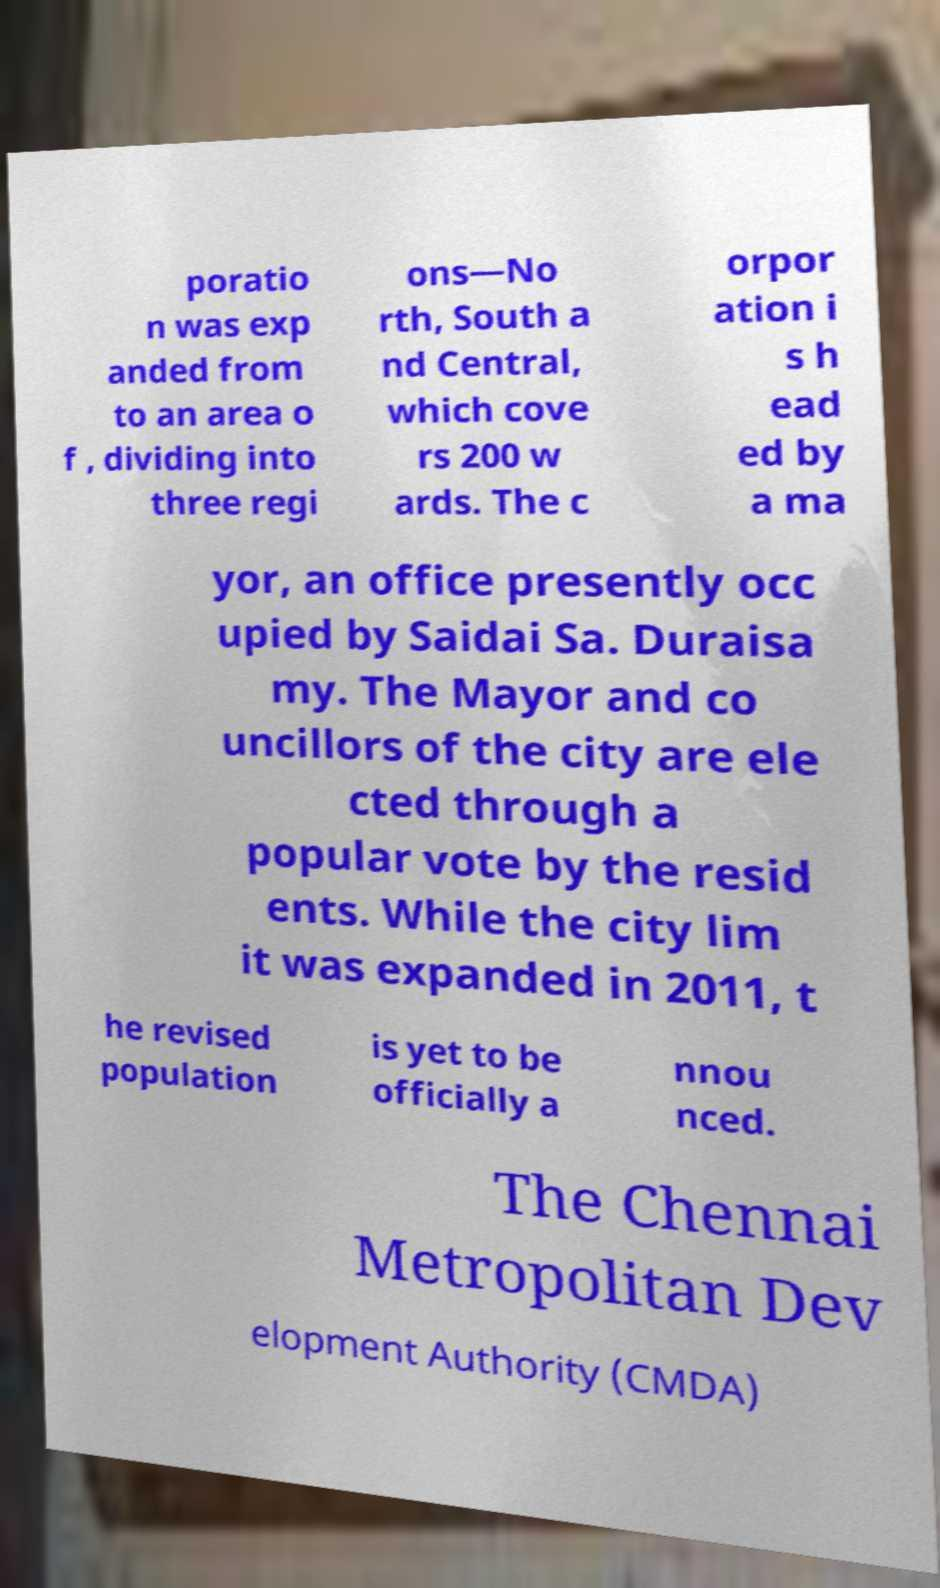Can you read and provide the text displayed in the image?This photo seems to have some interesting text. Can you extract and type it out for me? poratio n was exp anded from to an area o f , dividing into three regi ons—No rth, South a nd Central, which cove rs 200 w ards. The c orpor ation i s h ead ed by a ma yor, an office presently occ upied by Saidai Sa. Duraisa my. The Mayor and co uncillors of the city are ele cted through a popular vote by the resid ents. While the city lim it was expanded in 2011, t he revised population is yet to be officially a nnou nced. The Chennai Metropolitan Dev elopment Authority (CMDA) 